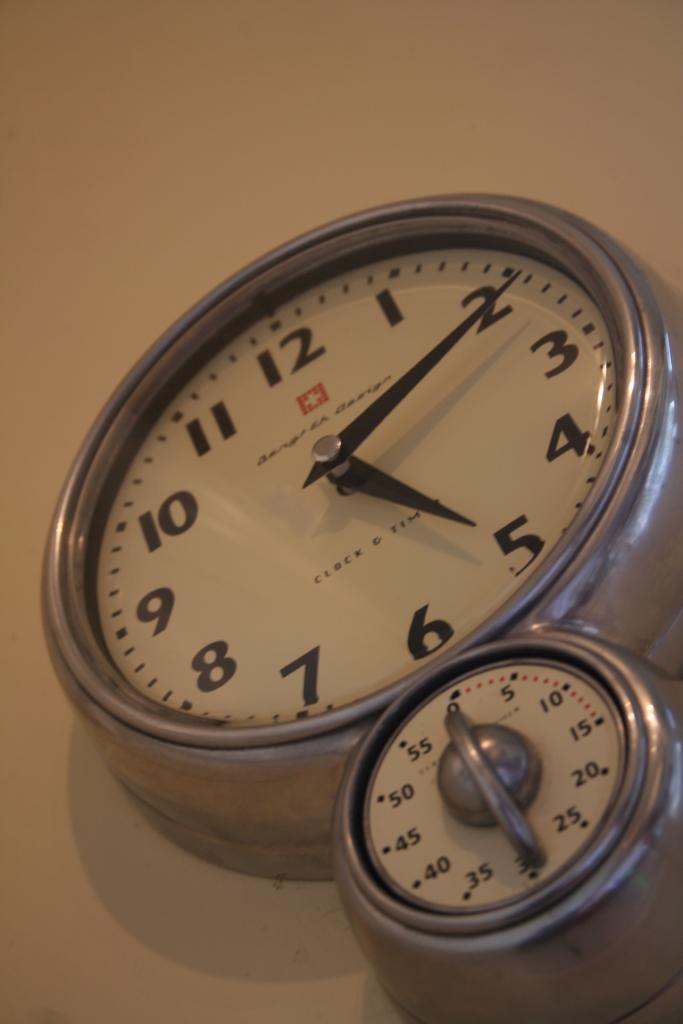What time is it?
Ensure brevity in your answer.  5:11. What does the timer below say?
Your answer should be very brief. 30. 